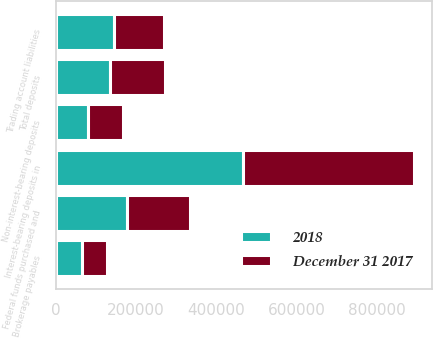<chart> <loc_0><loc_0><loc_500><loc_500><stacked_bar_chart><ecel><fcel>Non-interest-bearing deposits<fcel>Interest-bearing deposits in<fcel>Total deposits<fcel>Federal funds purchased and<fcel>Brokerage payables<fcel>Trading account liabilities<nl><fcel>2018<fcel>80648<fcel>465113<fcel>135592<fcel>177768<fcel>64571<fcel>144305<nl><fcel>December 31 2017<fcel>87440<fcel>426889<fcel>135592<fcel>156277<fcel>61342<fcel>125170<nl></chart> 